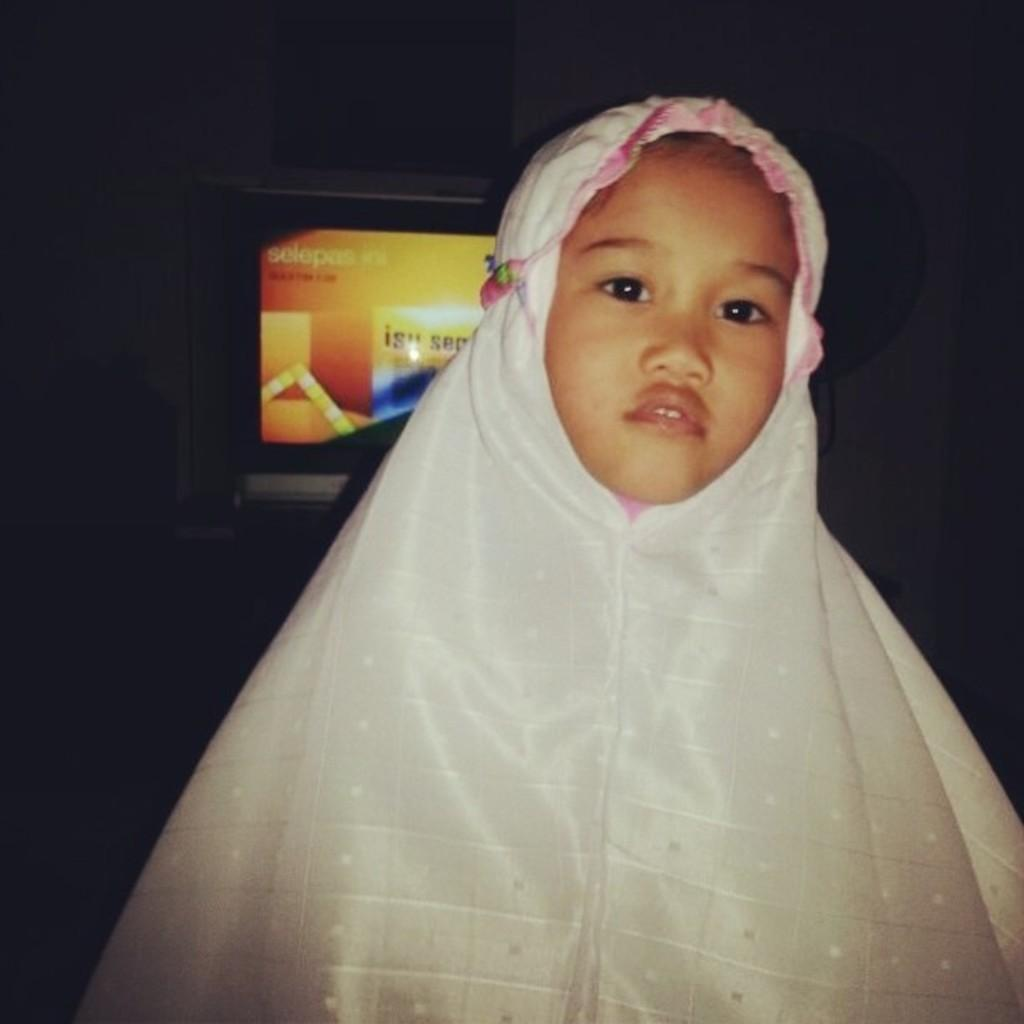What is the main subject in the foreground of the image? There is a girl in the foreground of the image. What is the girl wearing in the image? The girl is wearing a scarf in the image. What can be seen in the background of the image? There is a television and other objects in the background of the image. What type of structure is visible in the background of the image? There is a wall in the background of the image. How many babies are crawling on the wall in the image? There are no babies present in the image, and therefore no babies can be seen crawling on the wall. 